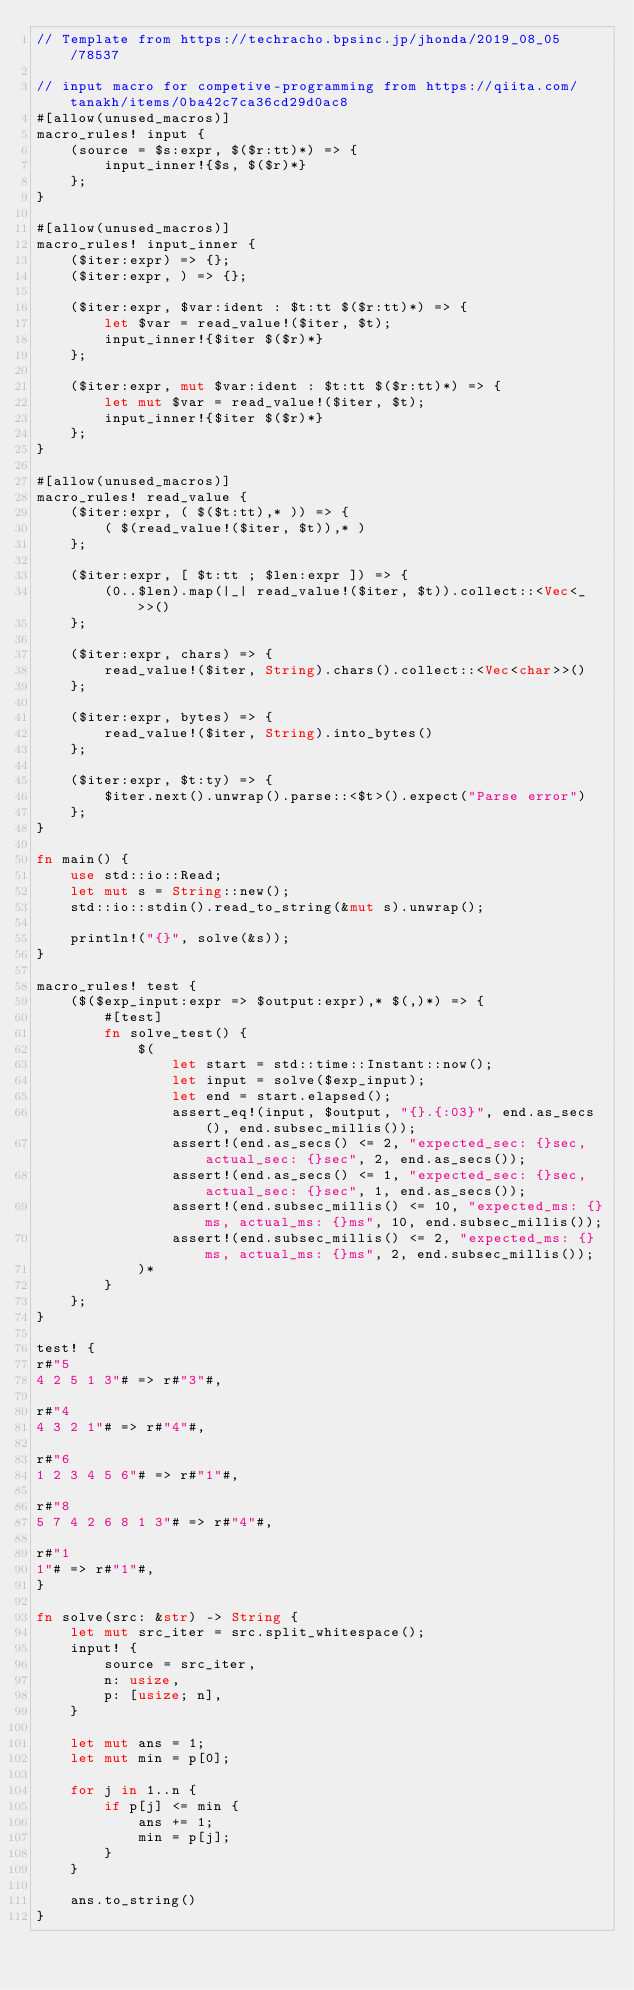Convert code to text. <code><loc_0><loc_0><loc_500><loc_500><_Rust_>// Template from https://techracho.bpsinc.jp/jhonda/2019_08_05/78537

// input macro for competive-programming from https://qiita.com/tanakh/items/0ba42c7ca36cd29d0ac8
#[allow(unused_macros)]
macro_rules! input {
    (source = $s:expr, $($r:tt)*) => {
        input_inner!{$s, $($r)*}
    };
}

#[allow(unused_macros)]
macro_rules! input_inner {
    ($iter:expr) => {};
    ($iter:expr, ) => {};

    ($iter:expr, $var:ident : $t:tt $($r:tt)*) => {
        let $var = read_value!($iter, $t);
        input_inner!{$iter $($r)*}
    };

    ($iter:expr, mut $var:ident : $t:tt $($r:tt)*) => {
        let mut $var = read_value!($iter, $t);
        input_inner!{$iter $($r)*}
    };
}

#[allow(unused_macros)]
macro_rules! read_value {
    ($iter:expr, ( $($t:tt),* )) => {
        ( $(read_value!($iter, $t)),* )
    };

    ($iter:expr, [ $t:tt ; $len:expr ]) => {
        (0..$len).map(|_| read_value!($iter, $t)).collect::<Vec<_>>()
    };

    ($iter:expr, chars) => {
        read_value!($iter, String).chars().collect::<Vec<char>>()
    };

    ($iter:expr, bytes) => {
        read_value!($iter, String).into_bytes()
    };

    ($iter:expr, $t:ty) => {
        $iter.next().unwrap().parse::<$t>().expect("Parse error")
    };
}

fn main() {
    use std::io::Read;
    let mut s = String::new();
    std::io::stdin().read_to_string(&mut s).unwrap();

    println!("{}", solve(&s));
}

macro_rules! test {
    ($($exp_input:expr => $output:expr),* $(,)*) => {
        #[test]
        fn solve_test() {
            $(
                let start = std::time::Instant::now();
                let input = solve($exp_input);
                let end = start.elapsed();
                assert_eq!(input, $output, "{}.{:03}", end.as_secs(), end.subsec_millis());
                assert!(end.as_secs() <= 2, "expected_sec: {}sec, actual_sec: {}sec", 2, end.as_secs());
                assert!(end.as_secs() <= 1, "expected_sec: {}sec, actual_sec: {}sec", 1, end.as_secs());
                assert!(end.subsec_millis() <= 10, "expected_ms: {}ms, actual_ms: {}ms", 10, end.subsec_millis());
                assert!(end.subsec_millis() <= 2, "expected_ms: {}ms, actual_ms: {}ms", 2, end.subsec_millis());
            )*
        }
    };
}

test! {
r#"5
4 2 5 1 3"# => r#"3"#,

r#"4
4 3 2 1"# => r#"4"#,

r#"6
1 2 3 4 5 6"# => r#"1"#,

r#"8
5 7 4 2 6 8 1 3"# => r#"4"#,

r#"1
1"# => r#"1"#,
}

fn solve(src: &str) -> String {
    let mut src_iter = src.split_whitespace();
    input! {
        source = src_iter,
        n: usize,
        p: [usize; n],
    }

    let mut ans = 1;
    let mut min = p[0];

    for j in 1..n {
        if p[j] <= min {
            ans += 1;
            min = p[j];
        }
    }

    ans.to_string()
}</code> 